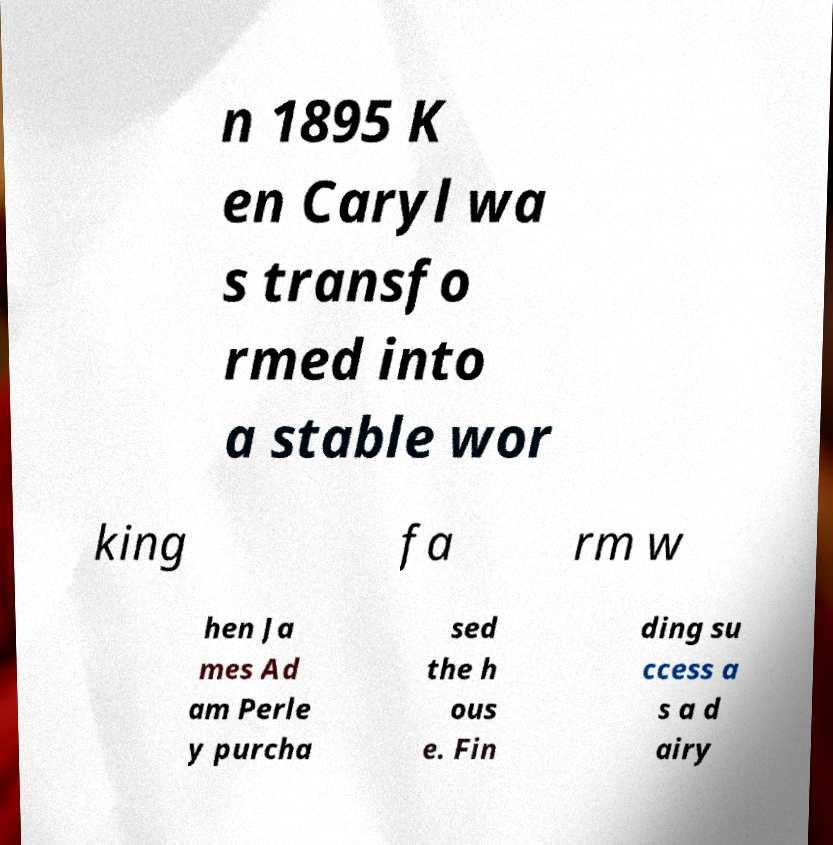I need the written content from this picture converted into text. Can you do that? n 1895 K en Caryl wa s transfo rmed into a stable wor king fa rm w hen Ja mes Ad am Perle y purcha sed the h ous e. Fin ding su ccess a s a d airy 